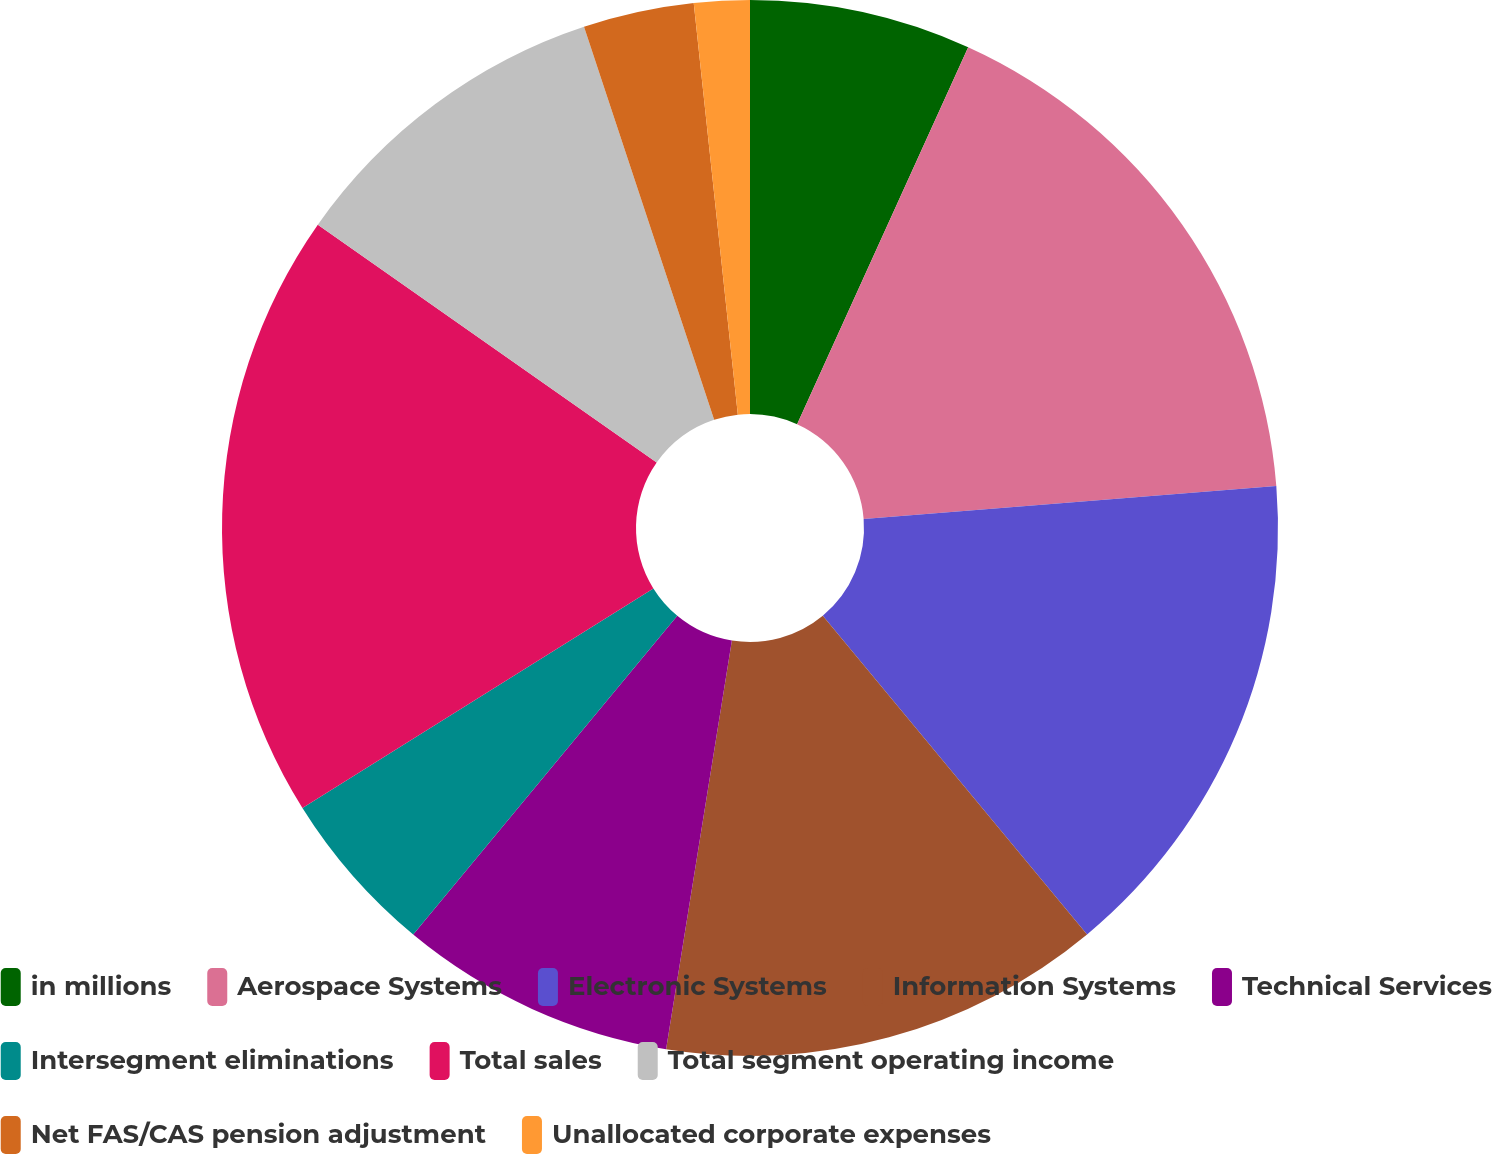Convert chart. <chart><loc_0><loc_0><loc_500><loc_500><pie_chart><fcel>in millions<fcel>Aerospace Systems<fcel>Electronic Systems<fcel>Information Systems<fcel>Technical Services<fcel>Intersegment eliminations<fcel>Total sales<fcel>Total segment operating income<fcel>Net FAS/CAS pension adjustment<fcel>Unallocated corporate expenses<nl><fcel>6.78%<fcel>16.95%<fcel>15.25%<fcel>13.56%<fcel>8.47%<fcel>5.09%<fcel>18.64%<fcel>10.17%<fcel>3.39%<fcel>1.7%<nl></chart> 